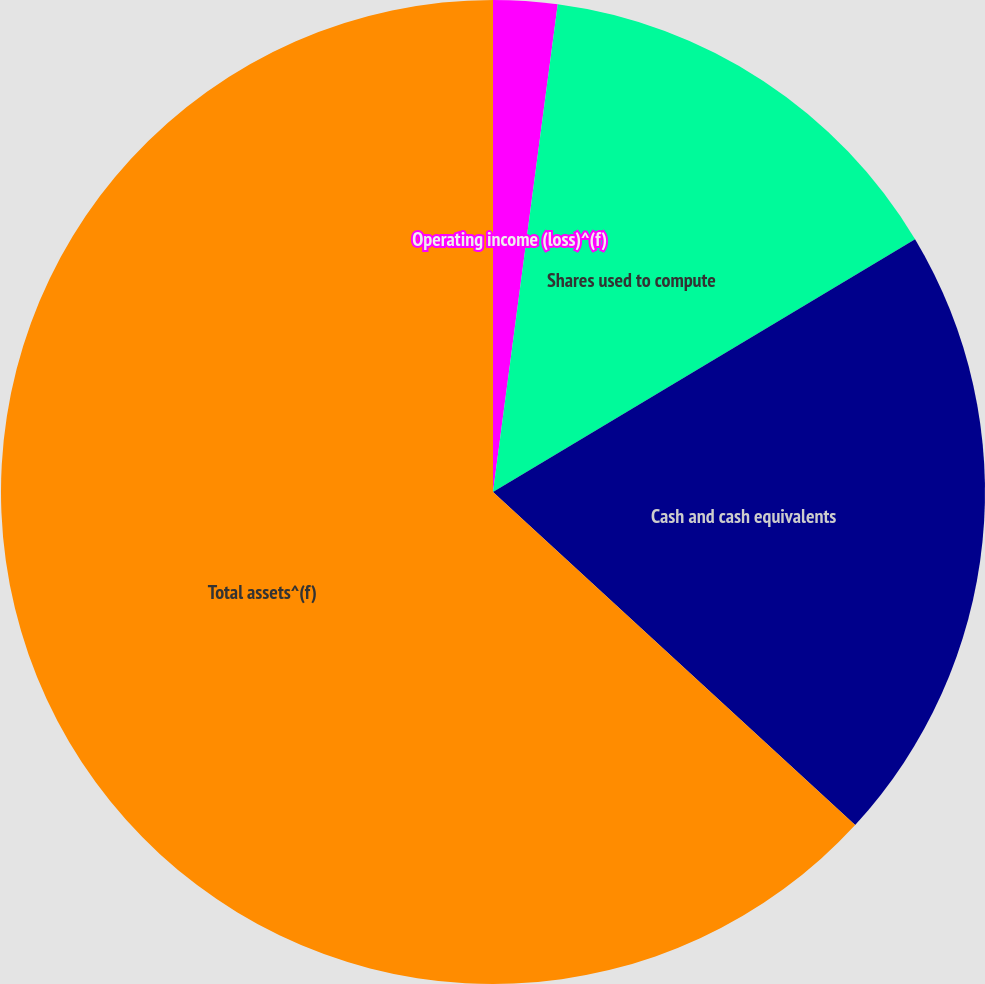Convert chart to OTSL. <chart><loc_0><loc_0><loc_500><loc_500><pie_chart><fcel>Operating income (loss)^(f)<fcel>Shares used to compute<fcel>Cash and cash equivalents<fcel>Total assets^(f)<nl><fcel>2.1%<fcel>14.31%<fcel>20.42%<fcel>63.16%<nl></chart> 